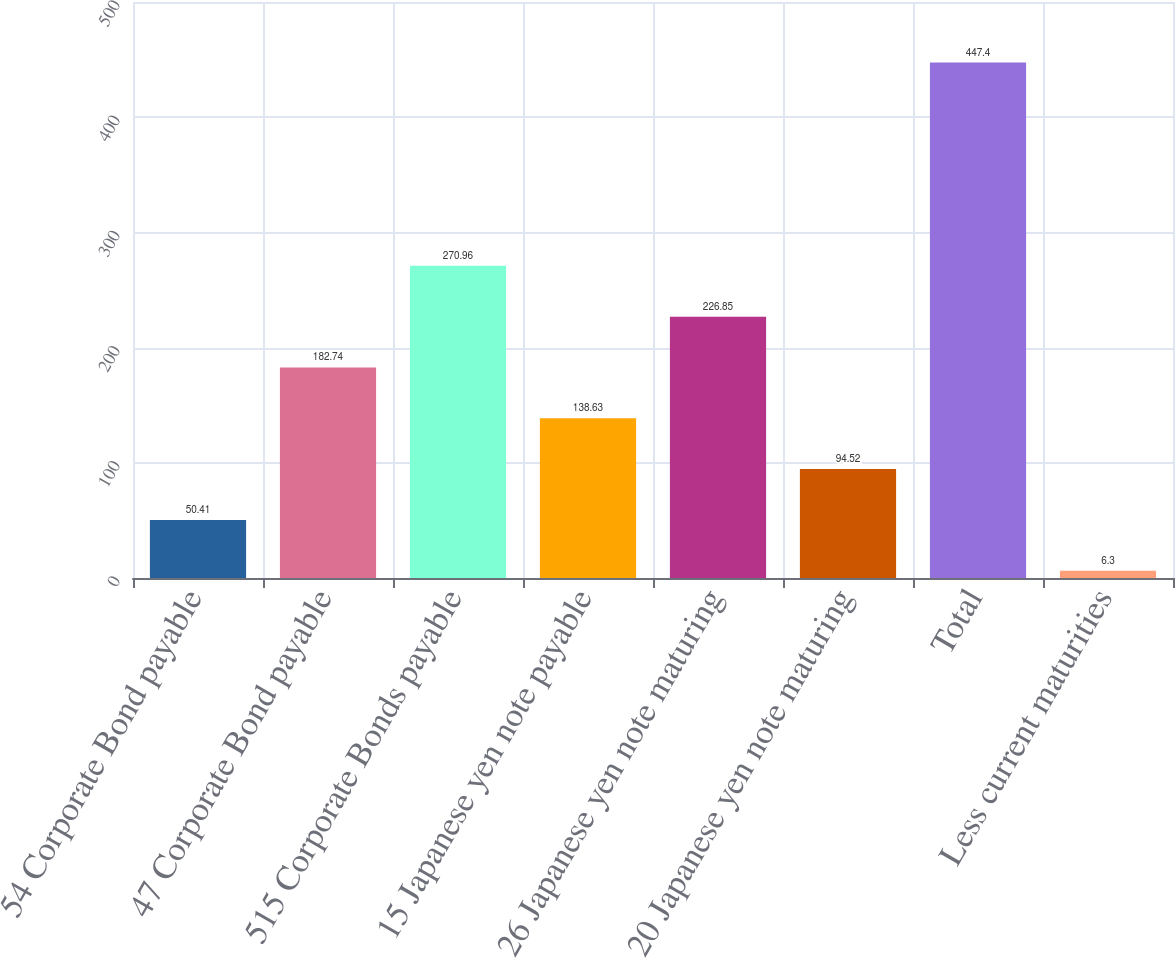Convert chart. <chart><loc_0><loc_0><loc_500><loc_500><bar_chart><fcel>54 Corporate Bond payable<fcel>47 Corporate Bond payable<fcel>515 Corporate Bonds payable<fcel>15 Japanese yen note payable<fcel>26 Japanese yen note maturing<fcel>20 Japanese yen note maturing<fcel>Total<fcel>Less current maturities<nl><fcel>50.41<fcel>182.74<fcel>270.96<fcel>138.63<fcel>226.85<fcel>94.52<fcel>447.4<fcel>6.3<nl></chart> 